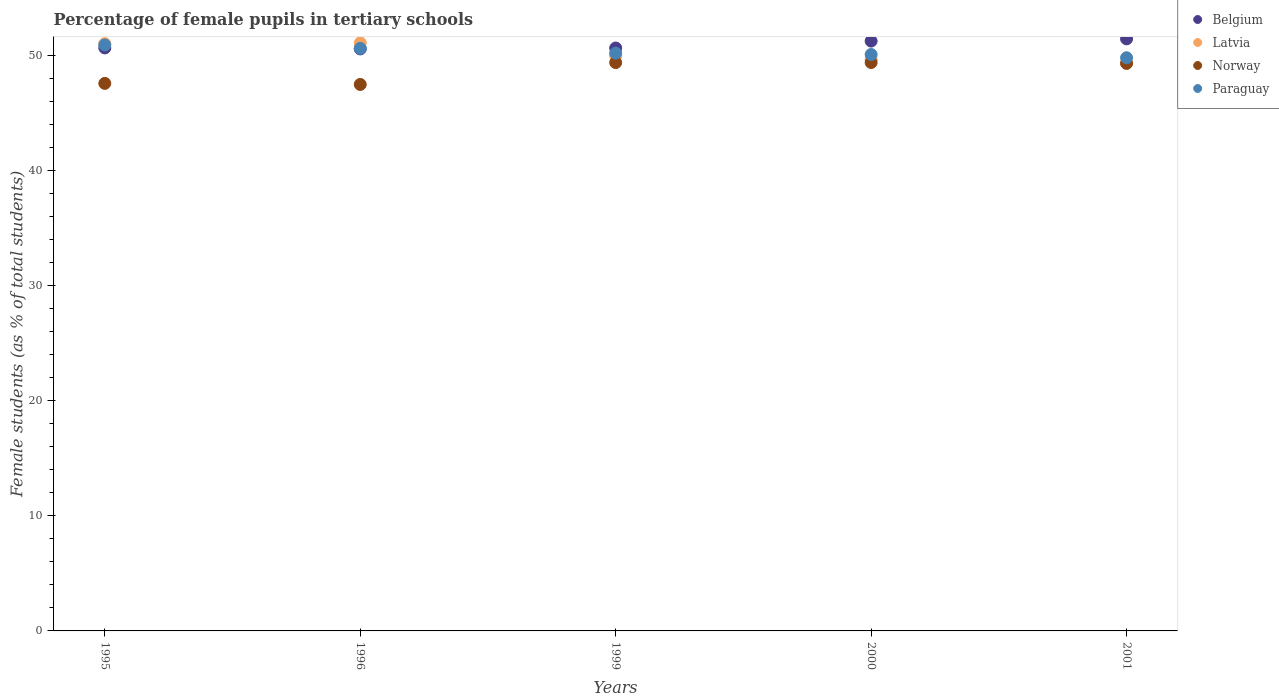What is the percentage of female pupils in tertiary schools in Norway in 1996?
Offer a terse response. 47.46. Across all years, what is the maximum percentage of female pupils in tertiary schools in Belgium?
Offer a terse response. 51.43. Across all years, what is the minimum percentage of female pupils in tertiary schools in Norway?
Your answer should be very brief. 47.46. What is the total percentage of female pupils in tertiary schools in Norway in the graph?
Ensure brevity in your answer.  243.05. What is the difference between the percentage of female pupils in tertiary schools in Latvia in 1995 and that in 1996?
Offer a terse response. -0.07. What is the difference between the percentage of female pupils in tertiary schools in Latvia in 1999 and the percentage of female pupils in tertiary schools in Paraguay in 2001?
Make the answer very short. 0.16. What is the average percentage of female pupils in tertiary schools in Belgium per year?
Offer a terse response. 50.9. In the year 1996, what is the difference between the percentage of female pupils in tertiary schools in Latvia and percentage of female pupils in tertiary schools in Belgium?
Your answer should be very brief. 0.53. What is the ratio of the percentage of female pupils in tertiary schools in Belgium in 1995 to that in 1996?
Provide a short and direct response. 1. Is the difference between the percentage of female pupils in tertiary schools in Latvia in 2000 and 2001 greater than the difference between the percentage of female pupils in tertiary schools in Belgium in 2000 and 2001?
Offer a terse response. Yes. What is the difference between the highest and the second highest percentage of female pupils in tertiary schools in Belgium?
Keep it short and to the point. 0.19. What is the difference between the highest and the lowest percentage of female pupils in tertiary schools in Norway?
Make the answer very short. 1.91. In how many years, is the percentage of female pupils in tertiary schools in Norway greater than the average percentage of female pupils in tertiary schools in Norway taken over all years?
Give a very brief answer. 3. Is the sum of the percentage of female pupils in tertiary schools in Paraguay in 1999 and 2000 greater than the maximum percentage of female pupils in tertiary schools in Latvia across all years?
Offer a terse response. Yes. Is it the case that in every year, the sum of the percentage of female pupils in tertiary schools in Paraguay and percentage of female pupils in tertiary schools in Latvia  is greater than the sum of percentage of female pupils in tertiary schools in Norway and percentage of female pupils in tertiary schools in Belgium?
Provide a short and direct response. No. Is it the case that in every year, the sum of the percentage of female pupils in tertiary schools in Belgium and percentage of female pupils in tertiary schools in Norway  is greater than the percentage of female pupils in tertiary schools in Latvia?
Your answer should be compact. Yes. Does the percentage of female pupils in tertiary schools in Paraguay monotonically increase over the years?
Offer a very short reply. No. How many dotlines are there?
Your response must be concise. 4. What is the difference between two consecutive major ticks on the Y-axis?
Provide a short and direct response. 10. Are the values on the major ticks of Y-axis written in scientific E-notation?
Your response must be concise. No. Does the graph contain any zero values?
Provide a short and direct response. No. Where does the legend appear in the graph?
Make the answer very short. Top right. How many legend labels are there?
Provide a succinct answer. 4. How are the legend labels stacked?
Keep it short and to the point. Vertical. What is the title of the graph?
Your answer should be compact. Percentage of female pupils in tertiary schools. What is the label or title of the Y-axis?
Your answer should be very brief. Female students (as % of total students). What is the Female students (as % of total students) of Belgium in 1995?
Provide a succinct answer. 50.64. What is the Female students (as % of total students) in Latvia in 1995?
Your answer should be very brief. 51.01. What is the Female students (as % of total students) of Norway in 1995?
Your answer should be very brief. 47.56. What is the Female students (as % of total students) in Paraguay in 1995?
Your answer should be very brief. 50.9. What is the Female students (as % of total students) in Belgium in 1996?
Ensure brevity in your answer.  50.55. What is the Female students (as % of total students) of Latvia in 1996?
Provide a short and direct response. 51.08. What is the Female students (as % of total students) in Norway in 1996?
Make the answer very short. 47.46. What is the Female students (as % of total students) in Paraguay in 1996?
Your answer should be compact. 50.6. What is the Female students (as % of total students) in Belgium in 1999?
Provide a succinct answer. 50.63. What is the Female students (as % of total students) of Latvia in 1999?
Make the answer very short. 49.95. What is the Female students (as % of total students) of Norway in 1999?
Your response must be concise. 49.36. What is the Female students (as % of total students) in Paraguay in 1999?
Offer a very short reply. 50.18. What is the Female students (as % of total students) of Belgium in 2000?
Provide a short and direct response. 51.23. What is the Female students (as % of total students) in Latvia in 2000?
Give a very brief answer. 49.65. What is the Female students (as % of total students) in Norway in 2000?
Your response must be concise. 49.37. What is the Female students (as % of total students) of Paraguay in 2000?
Offer a terse response. 50.06. What is the Female students (as % of total students) of Belgium in 2001?
Give a very brief answer. 51.43. What is the Female students (as % of total students) of Latvia in 2001?
Offer a terse response. 49.32. What is the Female students (as % of total students) in Norway in 2001?
Keep it short and to the point. 49.3. What is the Female students (as % of total students) in Paraguay in 2001?
Make the answer very short. 49.78. Across all years, what is the maximum Female students (as % of total students) of Belgium?
Your answer should be very brief. 51.43. Across all years, what is the maximum Female students (as % of total students) of Latvia?
Make the answer very short. 51.08. Across all years, what is the maximum Female students (as % of total students) in Norway?
Offer a very short reply. 49.37. Across all years, what is the maximum Female students (as % of total students) in Paraguay?
Offer a very short reply. 50.9. Across all years, what is the minimum Female students (as % of total students) in Belgium?
Your answer should be very brief. 50.55. Across all years, what is the minimum Female students (as % of total students) in Latvia?
Your answer should be compact. 49.32. Across all years, what is the minimum Female students (as % of total students) in Norway?
Offer a very short reply. 47.46. Across all years, what is the minimum Female students (as % of total students) of Paraguay?
Offer a terse response. 49.78. What is the total Female students (as % of total students) in Belgium in the graph?
Your answer should be compact. 254.48. What is the total Female students (as % of total students) of Latvia in the graph?
Provide a short and direct response. 251. What is the total Female students (as % of total students) of Norway in the graph?
Keep it short and to the point. 243.05. What is the total Female students (as % of total students) of Paraguay in the graph?
Your answer should be very brief. 251.53. What is the difference between the Female students (as % of total students) in Belgium in 1995 and that in 1996?
Your answer should be very brief. 0.09. What is the difference between the Female students (as % of total students) in Latvia in 1995 and that in 1996?
Offer a very short reply. -0.07. What is the difference between the Female students (as % of total students) in Norway in 1995 and that in 1996?
Provide a short and direct response. 0.09. What is the difference between the Female students (as % of total students) in Paraguay in 1995 and that in 1996?
Make the answer very short. 0.29. What is the difference between the Female students (as % of total students) in Belgium in 1995 and that in 1999?
Give a very brief answer. 0.01. What is the difference between the Female students (as % of total students) of Latvia in 1995 and that in 1999?
Provide a succinct answer. 1.06. What is the difference between the Female students (as % of total students) of Norway in 1995 and that in 1999?
Provide a succinct answer. -1.81. What is the difference between the Female students (as % of total students) in Paraguay in 1995 and that in 1999?
Your answer should be very brief. 0.71. What is the difference between the Female students (as % of total students) of Belgium in 1995 and that in 2000?
Keep it short and to the point. -0.59. What is the difference between the Female students (as % of total students) of Latvia in 1995 and that in 2000?
Offer a terse response. 1.35. What is the difference between the Female students (as % of total students) in Norway in 1995 and that in 2000?
Ensure brevity in your answer.  -1.81. What is the difference between the Female students (as % of total students) of Paraguay in 1995 and that in 2000?
Keep it short and to the point. 0.83. What is the difference between the Female students (as % of total students) of Belgium in 1995 and that in 2001?
Your response must be concise. -0.79. What is the difference between the Female students (as % of total students) of Latvia in 1995 and that in 2001?
Ensure brevity in your answer.  1.69. What is the difference between the Female students (as % of total students) in Norway in 1995 and that in 2001?
Offer a very short reply. -1.74. What is the difference between the Female students (as % of total students) in Paraguay in 1995 and that in 2001?
Offer a terse response. 1.11. What is the difference between the Female students (as % of total students) of Belgium in 1996 and that in 1999?
Make the answer very short. -0.08. What is the difference between the Female students (as % of total students) of Latvia in 1996 and that in 1999?
Give a very brief answer. 1.13. What is the difference between the Female students (as % of total students) of Norway in 1996 and that in 1999?
Your answer should be very brief. -1.9. What is the difference between the Female students (as % of total students) in Paraguay in 1996 and that in 1999?
Your answer should be compact. 0.42. What is the difference between the Female students (as % of total students) in Belgium in 1996 and that in 2000?
Offer a terse response. -0.68. What is the difference between the Female students (as % of total students) of Latvia in 1996 and that in 2000?
Your response must be concise. 1.43. What is the difference between the Female students (as % of total students) of Norway in 1996 and that in 2000?
Give a very brief answer. -1.91. What is the difference between the Female students (as % of total students) in Paraguay in 1996 and that in 2000?
Keep it short and to the point. 0.54. What is the difference between the Female students (as % of total students) of Belgium in 1996 and that in 2001?
Keep it short and to the point. -0.88. What is the difference between the Female students (as % of total students) in Latvia in 1996 and that in 2001?
Your response must be concise. 1.76. What is the difference between the Female students (as % of total students) in Norway in 1996 and that in 2001?
Provide a succinct answer. -1.83. What is the difference between the Female students (as % of total students) in Paraguay in 1996 and that in 2001?
Give a very brief answer. 0.82. What is the difference between the Female students (as % of total students) of Belgium in 1999 and that in 2000?
Provide a succinct answer. -0.6. What is the difference between the Female students (as % of total students) in Latvia in 1999 and that in 2000?
Provide a short and direct response. 0.3. What is the difference between the Female students (as % of total students) in Norway in 1999 and that in 2000?
Offer a terse response. -0.01. What is the difference between the Female students (as % of total students) in Paraguay in 1999 and that in 2000?
Your answer should be very brief. 0.12. What is the difference between the Female students (as % of total students) of Belgium in 1999 and that in 2001?
Your answer should be compact. -0.8. What is the difference between the Female students (as % of total students) in Latvia in 1999 and that in 2001?
Ensure brevity in your answer.  0.63. What is the difference between the Female students (as % of total students) of Norway in 1999 and that in 2001?
Keep it short and to the point. 0.07. What is the difference between the Female students (as % of total students) in Paraguay in 1999 and that in 2001?
Provide a succinct answer. 0.4. What is the difference between the Female students (as % of total students) in Belgium in 2000 and that in 2001?
Your response must be concise. -0.19. What is the difference between the Female students (as % of total students) in Latvia in 2000 and that in 2001?
Give a very brief answer. 0.34. What is the difference between the Female students (as % of total students) in Norway in 2000 and that in 2001?
Your response must be concise. 0.08. What is the difference between the Female students (as % of total students) of Paraguay in 2000 and that in 2001?
Ensure brevity in your answer.  0.28. What is the difference between the Female students (as % of total students) in Belgium in 1995 and the Female students (as % of total students) in Latvia in 1996?
Your answer should be compact. -0.44. What is the difference between the Female students (as % of total students) in Belgium in 1995 and the Female students (as % of total students) in Norway in 1996?
Your answer should be very brief. 3.17. What is the difference between the Female students (as % of total students) of Belgium in 1995 and the Female students (as % of total students) of Paraguay in 1996?
Your answer should be very brief. 0.04. What is the difference between the Female students (as % of total students) in Latvia in 1995 and the Female students (as % of total students) in Norway in 1996?
Provide a short and direct response. 3.54. What is the difference between the Female students (as % of total students) of Latvia in 1995 and the Female students (as % of total students) of Paraguay in 1996?
Your answer should be very brief. 0.4. What is the difference between the Female students (as % of total students) of Norway in 1995 and the Female students (as % of total students) of Paraguay in 1996?
Provide a short and direct response. -3.04. What is the difference between the Female students (as % of total students) in Belgium in 1995 and the Female students (as % of total students) in Latvia in 1999?
Your answer should be very brief. 0.69. What is the difference between the Female students (as % of total students) in Belgium in 1995 and the Female students (as % of total students) in Norway in 1999?
Your answer should be very brief. 1.27. What is the difference between the Female students (as % of total students) in Belgium in 1995 and the Female students (as % of total students) in Paraguay in 1999?
Make the answer very short. 0.46. What is the difference between the Female students (as % of total students) of Latvia in 1995 and the Female students (as % of total students) of Norway in 1999?
Offer a very short reply. 1.64. What is the difference between the Female students (as % of total students) in Latvia in 1995 and the Female students (as % of total students) in Paraguay in 1999?
Your response must be concise. 0.82. What is the difference between the Female students (as % of total students) in Norway in 1995 and the Female students (as % of total students) in Paraguay in 1999?
Offer a terse response. -2.63. What is the difference between the Female students (as % of total students) of Belgium in 1995 and the Female students (as % of total students) of Latvia in 2000?
Provide a succinct answer. 0.99. What is the difference between the Female students (as % of total students) in Belgium in 1995 and the Female students (as % of total students) in Norway in 2000?
Make the answer very short. 1.27. What is the difference between the Female students (as % of total students) of Belgium in 1995 and the Female students (as % of total students) of Paraguay in 2000?
Your response must be concise. 0.57. What is the difference between the Female students (as % of total students) of Latvia in 1995 and the Female students (as % of total students) of Norway in 2000?
Offer a terse response. 1.64. What is the difference between the Female students (as % of total students) in Latvia in 1995 and the Female students (as % of total students) in Paraguay in 2000?
Keep it short and to the point. 0.94. What is the difference between the Female students (as % of total students) of Norway in 1995 and the Female students (as % of total students) of Paraguay in 2000?
Offer a very short reply. -2.51. What is the difference between the Female students (as % of total students) in Belgium in 1995 and the Female students (as % of total students) in Latvia in 2001?
Your answer should be compact. 1.32. What is the difference between the Female students (as % of total students) of Belgium in 1995 and the Female students (as % of total students) of Norway in 2001?
Your answer should be compact. 1.34. What is the difference between the Female students (as % of total students) of Belgium in 1995 and the Female students (as % of total students) of Paraguay in 2001?
Provide a short and direct response. 0.85. What is the difference between the Female students (as % of total students) in Latvia in 1995 and the Female students (as % of total students) in Norway in 2001?
Offer a very short reply. 1.71. What is the difference between the Female students (as % of total students) of Latvia in 1995 and the Female students (as % of total students) of Paraguay in 2001?
Make the answer very short. 1.22. What is the difference between the Female students (as % of total students) of Norway in 1995 and the Female students (as % of total students) of Paraguay in 2001?
Provide a short and direct response. -2.23. What is the difference between the Female students (as % of total students) of Belgium in 1996 and the Female students (as % of total students) of Latvia in 1999?
Provide a short and direct response. 0.6. What is the difference between the Female students (as % of total students) of Belgium in 1996 and the Female students (as % of total students) of Norway in 1999?
Your answer should be very brief. 1.19. What is the difference between the Female students (as % of total students) of Belgium in 1996 and the Female students (as % of total students) of Paraguay in 1999?
Your response must be concise. 0.37. What is the difference between the Female students (as % of total students) in Latvia in 1996 and the Female students (as % of total students) in Norway in 1999?
Make the answer very short. 1.72. What is the difference between the Female students (as % of total students) in Latvia in 1996 and the Female students (as % of total students) in Paraguay in 1999?
Offer a very short reply. 0.9. What is the difference between the Female students (as % of total students) of Norway in 1996 and the Female students (as % of total students) of Paraguay in 1999?
Your response must be concise. -2.72. What is the difference between the Female students (as % of total students) in Belgium in 1996 and the Female students (as % of total students) in Latvia in 2000?
Give a very brief answer. 0.9. What is the difference between the Female students (as % of total students) in Belgium in 1996 and the Female students (as % of total students) in Norway in 2000?
Provide a short and direct response. 1.18. What is the difference between the Female students (as % of total students) in Belgium in 1996 and the Female students (as % of total students) in Paraguay in 2000?
Provide a short and direct response. 0.49. What is the difference between the Female students (as % of total students) in Latvia in 1996 and the Female students (as % of total students) in Norway in 2000?
Your answer should be compact. 1.71. What is the difference between the Female students (as % of total students) of Latvia in 1996 and the Female students (as % of total students) of Paraguay in 2000?
Provide a succinct answer. 1.02. What is the difference between the Female students (as % of total students) in Norway in 1996 and the Female students (as % of total students) in Paraguay in 2000?
Provide a succinct answer. -2.6. What is the difference between the Female students (as % of total students) of Belgium in 1996 and the Female students (as % of total students) of Latvia in 2001?
Ensure brevity in your answer.  1.23. What is the difference between the Female students (as % of total students) of Belgium in 1996 and the Female students (as % of total students) of Norway in 2001?
Provide a succinct answer. 1.25. What is the difference between the Female students (as % of total students) in Belgium in 1996 and the Female students (as % of total students) in Paraguay in 2001?
Offer a very short reply. 0.77. What is the difference between the Female students (as % of total students) of Latvia in 1996 and the Female students (as % of total students) of Norway in 2001?
Your response must be concise. 1.78. What is the difference between the Female students (as % of total students) of Latvia in 1996 and the Female students (as % of total students) of Paraguay in 2001?
Your response must be concise. 1.3. What is the difference between the Female students (as % of total students) of Norway in 1996 and the Female students (as % of total students) of Paraguay in 2001?
Make the answer very short. -2.32. What is the difference between the Female students (as % of total students) in Belgium in 1999 and the Female students (as % of total students) in Latvia in 2000?
Offer a terse response. 0.98. What is the difference between the Female students (as % of total students) in Belgium in 1999 and the Female students (as % of total students) in Norway in 2000?
Keep it short and to the point. 1.26. What is the difference between the Female students (as % of total students) in Belgium in 1999 and the Female students (as % of total students) in Paraguay in 2000?
Provide a short and direct response. 0.57. What is the difference between the Female students (as % of total students) in Latvia in 1999 and the Female students (as % of total students) in Norway in 2000?
Offer a terse response. 0.58. What is the difference between the Female students (as % of total students) of Latvia in 1999 and the Female students (as % of total students) of Paraguay in 2000?
Your answer should be compact. -0.12. What is the difference between the Female students (as % of total students) of Norway in 1999 and the Female students (as % of total students) of Paraguay in 2000?
Offer a terse response. -0.7. What is the difference between the Female students (as % of total students) of Belgium in 1999 and the Female students (as % of total students) of Latvia in 2001?
Make the answer very short. 1.31. What is the difference between the Female students (as % of total students) in Belgium in 1999 and the Female students (as % of total students) in Norway in 2001?
Give a very brief answer. 1.33. What is the difference between the Female students (as % of total students) of Belgium in 1999 and the Female students (as % of total students) of Paraguay in 2001?
Offer a terse response. 0.85. What is the difference between the Female students (as % of total students) in Latvia in 1999 and the Female students (as % of total students) in Norway in 2001?
Offer a very short reply. 0.65. What is the difference between the Female students (as % of total students) of Latvia in 1999 and the Female students (as % of total students) of Paraguay in 2001?
Make the answer very short. 0.16. What is the difference between the Female students (as % of total students) in Norway in 1999 and the Female students (as % of total students) in Paraguay in 2001?
Provide a succinct answer. -0.42. What is the difference between the Female students (as % of total students) in Belgium in 2000 and the Female students (as % of total students) in Latvia in 2001?
Provide a succinct answer. 1.92. What is the difference between the Female students (as % of total students) of Belgium in 2000 and the Female students (as % of total students) of Norway in 2001?
Your answer should be very brief. 1.94. What is the difference between the Female students (as % of total students) of Belgium in 2000 and the Female students (as % of total students) of Paraguay in 2001?
Your answer should be very brief. 1.45. What is the difference between the Female students (as % of total students) in Latvia in 2000 and the Female students (as % of total students) in Norway in 2001?
Offer a terse response. 0.36. What is the difference between the Female students (as % of total students) of Latvia in 2000 and the Female students (as % of total students) of Paraguay in 2001?
Keep it short and to the point. -0.13. What is the difference between the Female students (as % of total students) of Norway in 2000 and the Female students (as % of total students) of Paraguay in 2001?
Offer a very short reply. -0.41. What is the average Female students (as % of total students) of Belgium per year?
Make the answer very short. 50.9. What is the average Female students (as % of total students) of Latvia per year?
Give a very brief answer. 50.2. What is the average Female students (as % of total students) in Norway per year?
Offer a very short reply. 48.61. What is the average Female students (as % of total students) in Paraguay per year?
Give a very brief answer. 50.31. In the year 1995, what is the difference between the Female students (as % of total students) of Belgium and Female students (as % of total students) of Latvia?
Your answer should be very brief. -0.37. In the year 1995, what is the difference between the Female students (as % of total students) in Belgium and Female students (as % of total students) in Norway?
Your answer should be compact. 3.08. In the year 1995, what is the difference between the Female students (as % of total students) in Belgium and Female students (as % of total students) in Paraguay?
Offer a very short reply. -0.26. In the year 1995, what is the difference between the Female students (as % of total students) in Latvia and Female students (as % of total students) in Norway?
Keep it short and to the point. 3.45. In the year 1995, what is the difference between the Female students (as % of total students) of Latvia and Female students (as % of total students) of Paraguay?
Ensure brevity in your answer.  0.11. In the year 1995, what is the difference between the Female students (as % of total students) in Norway and Female students (as % of total students) in Paraguay?
Keep it short and to the point. -3.34. In the year 1996, what is the difference between the Female students (as % of total students) of Belgium and Female students (as % of total students) of Latvia?
Provide a succinct answer. -0.53. In the year 1996, what is the difference between the Female students (as % of total students) of Belgium and Female students (as % of total students) of Norway?
Your response must be concise. 3.09. In the year 1996, what is the difference between the Female students (as % of total students) in Belgium and Female students (as % of total students) in Paraguay?
Offer a terse response. -0.05. In the year 1996, what is the difference between the Female students (as % of total students) in Latvia and Female students (as % of total students) in Norway?
Your answer should be very brief. 3.62. In the year 1996, what is the difference between the Female students (as % of total students) of Latvia and Female students (as % of total students) of Paraguay?
Offer a terse response. 0.48. In the year 1996, what is the difference between the Female students (as % of total students) in Norway and Female students (as % of total students) in Paraguay?
Offer a very short reply. -3.14. In the year 1999, what is the difference between the Female students (as % of total students) of Belgium and Female students (as % of total students) of Latvia?
Provide a succinct answer. 0.68. In the year 1999, what is the difference between the Female students (as % of total students) in Belgium and Female students (as % of total students) in Norway?
Your answer should be compact. 1.27. In the year 1999, what is the difference between the Female students (as % of total students) in Belgium and Female students (as % of total students) in Paraguay?
Your answer should be compact. 0.45. In the year 1999, what is the difference between the Female students (as % of total students) of Latvia and Female students (as % of total students) of Norway?
Ensure brevity in your answer.  0.58. In the year 1999, what is the difference between the Female students (as % of total students) in Latvia and Female students (as % of total students) in Paraguay?
Your response must be concise. -0.24. In the year 1999, what is the difference between the Female students (as % of total students) in Norway and Female students (as % of total students) in Paraguay?
Give a very brief answer. -0.82. In the year 2000, what is the difference between the Female students (as % of total students) of Belgium and Female students (as % of total students) of Latvia?
Provide a succinct answer. 1.58. In the year 2000, what is the difference between the Female students (as % of total students) of Belgium and Female students (as % of total students) of Norway?
Ensure brevity in your answer.  1.86. In the year 2000, what is the difference between the Female students (as % of total students) in Belgium and Female students (as % of total students) in Paraguay?
Your answer should be compact. 1.17. In the year 2000, what is the difference between the Female students (as % of total students) in Latvia and Female students (as % of total students) in Norway?
Your answer should be compact. 0.28. In the year 2000, what is the difference between the Female students (as % of total students) in Latvia and Female students (as % of total students) in Paraguay?
Your answer should be very brief. -0.41. In the year 2000, what is the difference between the Female students (as % of total students) of Norway and Female students (as % of total students) of Paraguay?
Give a very brief answer. -0.69. In the year 2001, what is the difference between the Female students (as % of total students) in Belgium and Female students (as % of total students) in Latvia?
Provide a short and direct response. 2.11. In the year 2001, what is the difference between the Female students (as % of total students) in Belgium and Female students (as % of total students) in Norway?
Your response must be concise. 2.13. In the year 2001, what is the difference between the Female students (as % of total students) of Belgium and Female students (as % of total students) of Paraguay?
Provide a succinct answer. 1.64. In the year 2001, what is the difference between the Female students (as % of total students) of Latvia and Female students (as % of total students) of Norway?
Keep it short and to the point. 0.02. In the year 2001, what is the difference between the Female students (as % of total students) in Latvia and Female students (as % of total students) in Paraguay?
Offer a terse response. -0.47. In the year 2001, what is the difference between the Female students (as % of total students) of Norway and Female students (as % of total students) of Paraguay?
Offer a terse response. -0.49. What is the ratio of the Female students (as % of total students) in Belgium in 1995 to that in 1996?
Offer a terse response. 1. What is the ratio of the Female students (as % of total students) in Paraguay in 1995 to that in 1996?
Your response must be concise. 1.01. What is the ratio of the Female students (as % of total students) of Latvia in 1995 to that in 1999?
Offer a very short reply. 1.02. What is the ratio of the Female students (as % of total students) in Norway in 1995 to that in 1999?
Give a very brief answer. 0.96. What is the ratio of the Female students (as % of total students) of Paraguay in 1995 to that in 1999?
Offer a terse response. 1.01. What is the ratio of the Female students (as % of total students) of Belgium in 1995 to that in 2000?
Provide a short and direct response. 0.99. What is the ratio of the Female students (as % of total students) in Latvia in 1995 to that in 2000?
Give a very brief answer. 1.03. What is the ratio of the Female students (as % of total students) in Norway in 1995 to that in 2000?
Make the answer very short. 0.96. What is the ratio of the Female students (as % of total students) of Paraguay in 1995 to that in 2000?
Give a very brief answer. 1.02. What is the ratio of the Female students (as % of total students) in Belgium in 1995 to that in 2001?
Give a very brief answer. 0.98. What is the ratio of the Female students (as % of total students) in Latvia in 1995 to that in 2001?
Ensure brevity in your answer.  1.03. What is the ratio of the Female students (as % of total students) of Norway in 1995 to that in 2001?
Your answer should be compact. 0.96. What is the ratio of the Female students (as % of total students) in Paraguay in 1995 to that in 2001?
Keep it short and to the point. 1.02. What is the ratio of the Female students (as % of total students) in Latvia in 1996 to that in 1999?
Provide a succinct answer. 1.02. What is the ratio of the Female students (as % of total students) of Norway in 1996 to that in 1999?
Make the answer very short. 0.96. What is the ratio of the Female students (as % of total students) in Paraguay in 1996 to that in 1999?
Offer a terse response. 1.01. What is the ratio of the Female students (as % of total students) of Belgium in 1996 to that in 2000?
Provide a short and direct response. 0.99. What is the ratio of the Female students (as % of total students) of Latvia in 1996 to that in 2000?
Keep it short and to the point. 1.03. What is the ratio of the Female students (as % of total students) in Norway in 1996 to that in 2000?
Make the answer very short. 0.96. What is the ratio of the Female students (as % of total students) of Paraguay in 1996 to that in 2000?
Your answer should be compact. 1.01. What is the ratio of the Female students (as % of total students) of Latvia in 1996 to that in 2001?
Keep it short and to the point. 1.04. What is the ratio of the Female students (as % of total students) in Norway in 1996 to that in 2001?
Ensure brevity in your answer.  0.96. What is the ratio of the Female students (as % of total students) of Paraguay in 1996 to that in 2001?
Provide a short and direct response. 1.02. What is the ratio of the Female students (as % of total students) in Latvia in 1999 to that in 2000?
Your response must be concise. 1.01. What is the ratio of the Female students (as % of total students) in Paraguay in 1999 to that in 2000?
Make the answer very short. 1. What is the ratio of the Female students (as % of total students) of Belgium in 1999 to that in 2001?
Keep it short and to the point. 0.98. What is the ratio of the Female students (as % of total students) in Latvia in 1999 to that in 2001?
Make the answer very short. 1.01. What is the ratio of the Female students (as % of total students) of Norway in 1999 to that in 2001?
Keep it short and to the point. 1. What is the ratio of the Female students (as % of total students) of Belgium in 2000 to that in 2001?
Provide a short and direct response. 1. What is the ratio of the Female students (as % of total students) in Latvia in 2000 to that in 2001?
Provide a short and direct response. 1.01. What is the ratio of the Female students (as % of total students) in Norway in 2000 to that in 2001?
Provide a short and direct response. 1. What is the ratio of the Female students (as % of total students) in Paraguay in 2000 to that in 2001?
Make the answer very short. 1.01. What is the difference between the highest and the second highest Female students (as % of total students) of Belgium?
Offer a terse response. 0.19. What is the difference between the highest and the second highest Female students (as % of total students) in Latvia?
Offer a terse response. 0.07. What is the difference between the highest and the second highest Female students (as % of total students) in Norway?
Your response must be concise. 0.01. What is the difference between the highest and the second highest Female students (as % of total students) in Paraguay?
Your response must be concise. 0.29. What is the difference between the highest and the lowest Female students (as % of total students) of Belgium?
Your answer should be compact. 0.88. What is the difference between the highest and the lowest Female students (as % of total students) in Latvia?
Your response must be concise. 1.76. What is the difference between the highest and the lowest Female students (as % of total students) of Norway?
Offer a terse response. 1.91. What is the difference between the highest and the lowest Female students (as % of total students) in Paraguay?
Ensure brevity in your answer.  1.11. 